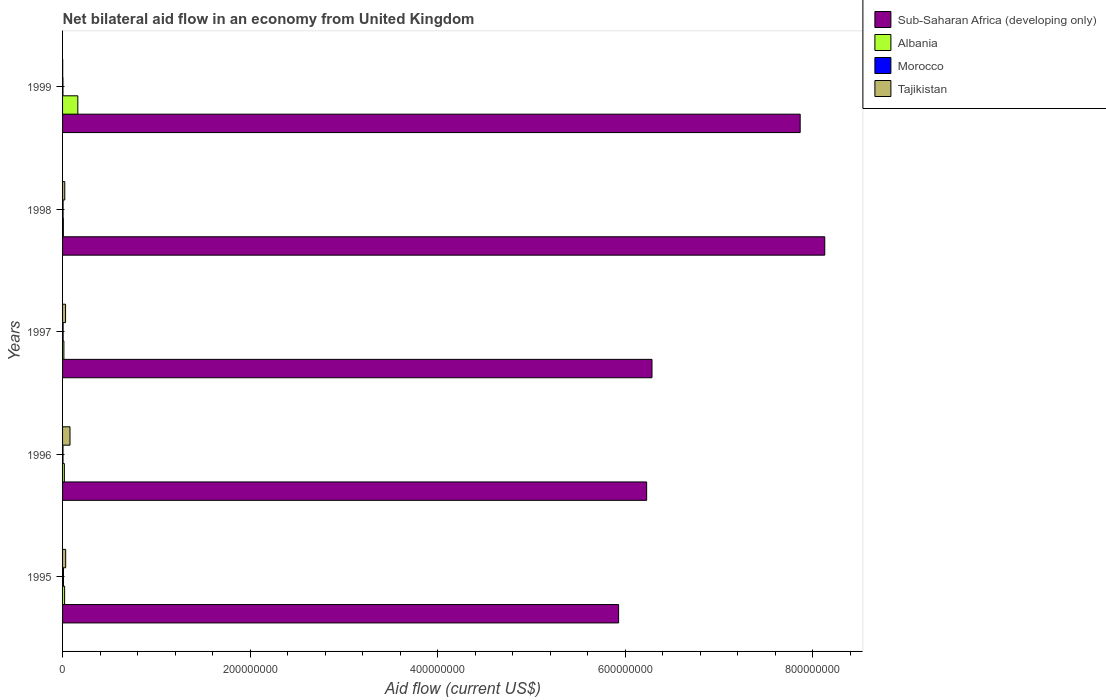Are the number of bars on each tick of the Y-axis equal?
Provide a short and direct response. Yes. How many bars are there on the 3rd tick from the top?
Make the answer very short. 4. What is the label of the 5th group of bars from the top?
Your answer should be very brief. 1995. Across all years, what is the maximum net bilateral aid flow in Morocco?
Your answer should be compact. 9.50e+05. Across all years, what is the minimum net bilateral aid flow in Tajikistan?
Ensure brevity in your answer.  1.30e+05. In which year was the net bilateral aid flow in Morocco minimum?
Keep it short and to the point. 1999. What is the total net bilateral aid flow in Morocco in the graph?
Provide a succinct answer. 2.96e+06. What is the difference between the net bilateral aid flow in Albania in 1995 and that in 1998?
Give a very brief answer. 1.33e+06. What is the difference between the net bilateral aid flow in Morocco in 1995 and the net bilateral aid flow in Albania in 1999?
Your answer should be very brief. -1.53e+07. What is the average net bilateral aid flow in Sub-Saharan Africa (developing only) per year?
Your response must be concise. 6.89e+08. In the year 1998, what is the difference between the net bilateral aid flow in Morocco and net bilateral aid flow in Sub-Saharan Africa (developing only)?
Provide a succinct answer. -8.12e+08. In how many years, is the net bilateral aid flow in Sub-Saharan Africa (developing only) greater than 160000000 US$?
Provide a short and direct response. 5. What is the ratio of the net bilateral aid flow in Tajikistan in 1995 to that in 1996?
Provide a short and direct response. 0.42. Is the net bilateral aid flow in Morocco in 1996 less than that in 1998?
Give a very brief answer. Yes. What is the difference between the highest and the second highest net bilateral aid flow in Albania?
Make the answer very short. 1.41e+07. What is the difference between the highest and the lowest net bilateral aid flow in Sub-Saharan Africa (developing only)?
Make the answer very short. 2.20e+08. What does the 3rd bar from the top in 1999 represents?
Keep it short and to the point. Albania. What does the 4th bar from the bottom in 1999 represents?
Offer a terse response. Tajikistan. Is it the case that in every year, the sum of the net bilateral aid flow in Morocco and net bilateral aid flow in Sub-Saharan Africa (developing only) is greater than the net bilateral aid flow in Tajikistan?
Your response must be concise. Yes. How many bars are there?
Provide a succinct answer. 20. Are the values on the major ticks of X-axis written in scientific E-notation?
Provide a succinct answer. No. How many legend labels are there?
Your answer should be compact. 4. What is the title of the graph?
Your response must be concise. Net bilateral aid flow in an economy from United Kingdom. Does "Monaco" appear as one of the legend labels in the graph?
Your answer should be compact. No. What is the Aid flow (current US$) of Sub-Saharan Africa (developing only) in 1995?
Provide a short and direct response. 5.93e+08. What is the Aid flow (current US$) of Albania in 1995?
Provide a short and direct response. 2.20e+06. What is the Aid flow (current US$) in Morocco in 1995?
Provide a succinct answer. 9.50e+05. What is the Aid flow (current US$) in Tajikistan in 1995?
Your response must be concise. 3.32e+06. What is the Aid flow (current US$) of Sub-Saharan Africa (developing only) in 1996?
Your answer should be very brief. 6.23e+08. What is the Aid flow (current US$) of Albania in 1996?
Make the answer very short. 1.91e+06. What is the Aid flow (current US$) in Morocco in 1996?
Your response must be concise. 4.70e+05. What is the Aid flow (current US$) of Tajikistan in 1996?
Keep it short and to the point. 7.93e+06. What is the Aid flow (current US$) in Sub-Saharan Africa (developing only) in 1997?
Ensure brevity in your answer.  6.28e+08. What is the Aid flow (current US$) of Albania in 1997?
Offer a very short reply. 1.42e+06. What is the Aid flow (current US$) of Morocco in 1997?
Provide a short and direct response. 5.80e+05. What is the Aid flow (current US$) in Tajikistan in 1997?
Provide a succinct answer. 3.19e+06. What is the Aid flow (current US$) of Sub-Saharan Africa (developing only) in 1998?
Give a very brief answer. 8.13e+08. What is the Aid flow (current US$) in Albania in 1998?
Keep it short and to the point. 8.70e+05. What is the Aid flow (current US$) of Morocco in 1998?
Give a very brief answer. 5.40e+05. What is the Aid flow (current US$) in Tajikistan in 1998?
Provide a short and direct response. 2.36e+06. What is the Aid flow (current US$) of Sub-Saharan Africa (developing only) in 1999?
Ensure brevity in your answer.  7.86e+08. What is the Aid flow (current US$) in Albania in 1999?
Your response must be concise. 1.63e+07. What is the Aid flow (current US$) of Morocco in 1999?
Your response must be concise. 4.20e+05. Across all years, what is the maximum Aid flow (current US$) in Sub-Saharan Africa (developing only)?
Your answer should be compact. 8.13e+08. Across all years, what is the maximum Aid flow (current US$) of Albania?
Ensure brevity in your answer.  1.63e+07. Across all years, what is the maximum Aid flow (current US$) in Morocco?
Offer a very short reply. 9.50e+05. Across all years, what is the maximum Aid flow (current US$) in Tajikistan?
Your answer should be very brief. 7.93e+06. Across all years, what is the minimum Aid flow (current US$) in Sub-Saharan Africa (developing only)?
Your response must be concise. 5.93e+08. Across all years, what is the minimum Aid flow (current US$) of Albania?
Keep it short and to the point. 8.70e+05. Across all years, what is the minimum Aid flow (current US$) of Morocco?
Ensure brevity in your answer.  4.20e+05. What is the total Aid flow (current US$) in Sub-Saharan Africa (developing only) in the graph?
Your answer should be compact. 3.44e+09. What is the total Aid flow (current US$) of Albania in the graph?
Your response must be concise. 2.27e+07. What is the total Aid flow (current US$) in Morocco in the graph?
Keep it short and to the point. 2.96e+06. What is the total Aid flow (current US$) in Tajikistan in the graph?
Ensure brevity in your answer.  1.69e+07. What is the difference between the Aid flow (current US$) in Sub-Saharan Africa (developing only) in 1995 and that in 1996?
Your answer should be compact. -2.99e+07. What is the difference between the Aid flow (current US$) of Tajikistan in 1995 and that in 1996?
Your answer should be very brief. -4.61e+06. What is the difference between the Aid flow (current US$) in Sub-Saharan Africa (developing only) in 1995 and that in 1997?
Give a very brief answer. -3.56e+07. What is the difference between the Aid flow (current US$) of Albania in 1995 and that in 1997?
Ensure brevity in your answer.  7.80e+05. What is the difference between the Aid flow (current US$) of Morocco in 1995 and that in 1997?
Offer a terse response. 3.70e+05. What is the difference between the Aid flow (current US$) of Tajikistan in 1995 and that in 1997?
Your response must be concise. 1.30e+05. What is the difference between the Aid flow (current US$) in Sub-Saharan Africa (developing only) in 1995 and that in 1998?
Provide a succinct answer. -2.20e+08. What is the difference between the Aid flow (current US$) in Albania in 1995 and that in 1998?
Your answer should be very brief. 1.33e+06. What is the difference between the Aid flow (current US$) of Tajikistan in 1995 and that in 1998?
Provide a short and direct response. 9.60e+05. What is the difference between the Aid flow (current US$) in Sub-Saharan Africa (developing only) in 1995 and that in 1999?
Your response must be concise. -1.94e+08. What is the difference between the Aid flow (current US$) in Albania in 1995 and that in 1999?
Offer a terse response. -1.41e+07. What is the difference between the Aid flow (current US$) in Morocco in 1995 and that in 1999?
Keep it short and to the point. 5.30e+05. What is the difference between the Aid flow (current US$) of Tajikistan in 1995 and that in 1999?
Your response must be concise. 3.19e+06. What is the difference between the Aid flow (current US$) of Sub-Saharan Africa (developing only) in 1996 and that in 1997?
Ensure brevity in your answer.  -5.70e+06. What is the difference between the Aid flow (current US$) of Tajikistan in 1996 and that in 1997?
Give a very brief answer. 4.74e+06. What is the difference between the Aid flow (current US$) in Sub-Saharan Africa (developing only) in 1996 and that in 1998?
Provide a succinct answer. -1.90e+08. What is the difference between the Aid flow (current US$) of Albania in 1996 and that in 1998?
Your answer should be very brief. 1.04e+06. What is the difference between the Aid flow (current US$) of Tajikistan in 1996 and that in 1998?
Give a very brief answer. 5.57e+06. What is the difference between the Aid flow (current US$) in Sub-Saharan Africa (developing only) in 1996 and that in 1999?
Your response must be concise. -1.64e+08. What is the difference between the Aid flow (current US$) of Albania in 1996 and that in 1999?
Give a very brief answer. -1.44e+07. What is the difference between the Aid flow (current US$) of Tajikistan in 1996 and that in 1999?
Ensure brevity in your answer.  7.80e+06. What is the difference between the Aid flow (current US$) of Sub-Saharan Africa (developing only) in 1997 and that in 1998?
Your response must be concise. -1.84e+08. What is the difference between the Aid flow (current US$) in Albania in 1997 and that in 1998?
Your answer should be very brief. 5.50e+05. What is the difference between the Aid flow (current US$) in Morocco in 1997 and that in 1998?
Make the answer very short. 4.00e+04. What is the difference between the Aid flow (current US$) of Tajikistan in 1997 and that in 1998?
Ensure brevity in your answer.  8.30e+05. What is the difference between the Aid flow (current US$) in Sub-Saharan Africa (developing only) in 1997 and that in 1999?
Make the answer very short. -1.58e+08. What is the difference between the Aid flow (current US$) in Albania in 1997 and that in 1999?
Make the answer very short. -1.49e+07. What is the difference between the Aid flow (current US$) in Tajikistan in 1997 and that in 1999?
Make the answer very short. 3.06e+06. What is the difference between the Aid flow (current US$) in Sub-Saharan Africa (developing only) in 1998 and that in 1999?
Provide a short and direct response. 2.62e+07. What is the difference between the Aid flow (current US$) of Albania in 1998 and that in 1999?
Keep it short and to the point. -1.54e+07. What is the difference between the Aid flow (current US$) of Morocco in 1998 and that in 1999?
Your answer should be compact. 1.20e+05. What is the difference between the Aid flow (current US$) in Tajikistan in 1998 and that in 1999?
Keep it short and to the point. 2.23e+06. What is the difference between the Aid flow (current US$) of Sub-Saharan Africa (developing only) in 1995 and the Aid flow (current US$) of Albania in 1996?
Your response must be concise. 5.91e+08. What is the difference between the Aid flow (current US$) of Sub-Saharan Africa (developing only) in 1995 and the Aid flow (current US$) of Morocco in 1996?
Offer a terse response. 5.92e+08. What is the difference between the Aid flow (current US$) in Sub-Saharan Africa (developing only) in 1995 and the Aid flow (current US$) in Tajikistan in 1996?
Offer a very short reply. 5.85e+08. What is the difference between the Aid flow (current US$) of Albania in 1995 and the Aid flow (current US$) of Morocco in 1996?
Offer a very short reply. 1.73e+06. What is the difference between the Aid flow (current US$) of Albania in 1995 and the Aid flow (current US$) of Tajikistan in 1996?
Your answer should be very brief. -5.73e+06. What is the difference between the Aid flow (current US$) of Morocco in 1995 and the Aid flow (current US$) of Tajikistan in 1996?
Make the answer very short. -6.98e+06. What is the difference between the Aid flow (current US$) of Sub-Saharan Africa (developing only) in 1995 and the Aid flow (current US$) of Albania in 1997?
Keep it short and to the point. 5.91e+08. What is the difference between the Aid flow (current US$) of Sub-Saharan Africa (developing only) in 1995 and the Aid flow (current US$) of Morocco in 1997?
Provide a succinct answer. 5.92e+08. What is the difference between the Aid flow (current US$) in Sub-Saharan Africa (developing only) in 1995 and the Aid flow (current US$) in Tajikistan in 1997?
Ensure brevity in your answer.  5.90e+08. What is the difference between the Aid flow (current US$) of Albania in 1995 and the Aid flow (current US$) of Morocco in 1997?
Ensure brevity in your answer.  1.62e+06. What is the difference between the Aid flow (current US$) in Albania in 1995 and the Aid flow (current US$) in Tajikistan in 1997?
Ensure brevity in your answer.  -9.90e+05. What is the difference between the Aid flow (current US$) in Morocco in 1995 and the Aid flow (current US$) in Tajikistan in 1997?
Keep it short and to the point. -2.24e+06. What is the difference between the Aid flow (current US$) of Sub-Saharan Africa (developing only) in 1995 and the Aid flow (current US$) of Albania in 1998?
Offer a terse response. 5.92e+08. What is the difference between the Aid flow (current US$) of Sub-Saharan Africa (developing only) in 1995 and the Aid flow (current US$) of Morocco in 1998?
Your response must be concise. 5.92e+08. What is the difference between the Aid flow (current US$) of Sub-Saharan Africa (developing only) in 1995 and the Aid flow (current US$) of Tajikistan in 1998?
Your answer should be very brief. 5.90e+08. What is the difference between the Aid flow (current US$) of Albania in 1995 and the Aid flow (current US$) of Morocco in 1998?
Your answer should be very brief. 1.66e+06. What is the difference between the Aid flow (current US$) of Albania in 1995 and the Aid flow (current US$) of Tajikistan in 1998?
Offer a very short reply. -1.60e+05. What is the difference between the Aid flow (current US$) of Morocco in 1995 and the Aid flow (current US$) of Tajikistan in 1998?
Your response must be concise. -1.41e+06. What is the difference between the Aid flow (current US$) of Sub-Saharan Africa (developing only) in 1995 and the Aid flow (current US$) of Albania in 1999?
Your answer should be very brief. 5.77e+08. What is the difference between the Aid flow (current US$) of Sub-Saharan Africa (developing only) in 1995 and the Aid flow (current US$) of Morocco in 1999?
Keep it short and to the point. 5.92e+08. What is the difference between the Aid flow (current US$) of Sub-Saharan Africa (developing only) in 1995 and the Aid flow (current US$) of Tajikistan in 1999?
Keep it short and to the point. 5.93e+08. What is the difference between the Aid flow (current US$) in Albania in 1995 and the Aid flow (current US$) in Morocco in 1999?
Your answer should be compact. 1.78e+06. What is the difference between the Aid flow (current US$) of Albania in 1995 and the Aid flow (current US$) of Tajikistan in 1999?
Give a very brief answer. 2.07e+06. What is the difference between the Aid flow (current US$) of Morocco in 1995 and the Aid flow (current US$) of Tajikistan in 1999?
Your answer should be very brief. 8.20e+05. What is the difference between the Aid flow (current US$) in Sub-Saharan Africa (developing only) in 1996 and the Aid flow (current US$) in Albania in 1997?
Provide a short and direct response. 6.21e+08. What is the difference between the Aid flow (current US$) of Sub-Saharan Africa (developing only) in 1996 and the Aid flow (current US$) of Morocco in 1997?
Keep it short and to the point. 6.22e+08. What is the difference between the Aid flow (current US$) in Sub-Saharan Africa (developing only) in 1996 and the Aid flow (current US$) in Tajikistan in 1997?
Your answer should be very brief. 6.20e+08. What is the difference between the Aid flow (current US$) of Albania in 1996 and the Aid flow (current US$) of Morocco in 1997?
Ensure brevity in your answer.  1.33e+06. What is the difference between the Aid flow (current US$) of Albania in 1996 and the Aid flow (current US$) of Tajikistan in 1997?
Offer a terse response. -1.28e+06. What is the difference between the Aid flow (current US$) in Morocco in 1996 and the Aid flow (current US$) in Tajikistan in 1997?
Your answer should be very brief. -2.72e+06. What is the difference between the Aid flow (current US$) of Sub-Saharan Africa (developing only) in 1996 and the Aid flow (current US$) of Albania in 1998?
Offer a terse response. 6.22e+08. What is the difference between the Aid flow (current US$) in Sub-Saharan Africa (developing only) in 1996 and the Aid flow (current US$) in Morocco in 1998?
Ensure brevity in your answer.  6.22e+08. What is the difference between the Aid flow (current US$) in Sub-Saharan Africa (developing only) in 1996 and the Aid flow (current US$) in Tajikistan in 1998?
Ensure brevity in your answer.  6.20e+08. What is the difference between the Aid flow (current US$) of Albania in 1996 and the Aid flow (current US$) of Morocco in 1998?
Offer a terse response. 1.37e+06. What is the difference between the Aid flow (current US$) in Albania in 1996 and the Aid flow (current US$) in Tajikistan in 1998?
Your answer should be compact. -4.50e+05. What is the difference between the Aid flow (current US$) of Morocco in 1996 and the Aid flow (current US$) of Tajikistan in 1998?
Your answer should be very brief. -1.89e+06. What is the difference between the Aid flow (current US$) of Sub-Saharan Africa (developing only) in 1996 and the Aid flow (current US$) of Albania in 1999?
Ensure brevity in your answer.  6.06e+08. What is the difference between the Aid flow (current US$) in Sub-Saharan Africa (developing only) in 1996 and the Aid flow (current US$) in Morocco in 1999?
Your response must be concise. 6.22e+08. What is the difference between the Aid flow (current US$) in Sub-Saharan Africa (developing only) in 1996 and the Aid flow (current US$) in Tajikistan in 1999?
Offer a very short reply. 6.23e+08. What is the difference between the Aid flow (current US$) of Albania in 1996 and the Aid flow (current US$) of Morocco in 1999?
Your answer should be compact. 1.49e+06. What is the difference between the Aid flow (current US$) in Albania in 1996 and the Aid flow (current US$) in Tajikistan in 1999?
Ensure brevity in your answer.  1.78e+06. What is the difference between the Aid flow (current US$) of Sub-Saharan Africa (developing only) in 1997 and the Aid flow (current US$) of Albania in 1998?
Your response must be concise. 6.28e+08. What is the difference between the Aid flow (current US$) of Sub-Saharan Africa (developing only) in 1997 and the Aid flow (current US$) of Morocco in 1998?
Provide a short and direct response. 6.28e+08. What is the difference between the Aid flow (current US$) of Sub-Saharan Africa (developing only) in 1997 and the Aid flow (current US$) of Tajikistan in 1998?
Provide a short and direct response. 6.26e+08. What is the difference between the Aid flow (current US$) of Albania in 1997 and the Aid flow (current US$) of Morocco in 1998?
Provide a succinct answer. 8.80e+05. What is the difference between the Aid flow (current US$) in Albania in 1997 and the Aid flow (current US$) in Tajikistan in 1998?
Make the answer very short. -9.40e+05. What is the difference between the Aid flow (current US$) of Morocco in 1997 and the Aid flow (current US$) of Tajikistan in 1998?
Ensure brevity in your answer.  -1.78e+06. What is the difference between the Aid flow (current US$) in Sub-Saharan Africa (developing only) in 1997 and the Aid flow (current US$) in Albania in 1999?
Give a very brief answer. 6.12e+08. What is the difference between the Aid flow (current US$) in Sub-Saharan Africa (developing only) in 1997 and the Aid flow (current US$) in Morocco in 1999?
Give a very brief answer. 6.28e+08. What is the difference between the Aid flow (current US$) in Sub-Saharan Africa (developing only) in 1997 and the Aid flow (current US$) in Tajikistan in 1999?
Offer a terse response. 6.28e+08. What is the difference between the Aid flow (current US$) in Albania in 1997 and the Aid flow (current US$) in Tajikistan in 1999?
Your response must be concise. 1.29e+06. What is the difference between the Aid flow (current US$) of Morocco in 1997 and the Aid flow (current US$) of Tajikistan in 1999?
Ensure brevity in your answer.  4.50e+05. What is the difference between the Aid flow (current US$) of Sub-Saharan Africa (developing only) in 1998 and the Aid flow (current US$) of Albania in 1999?
Make the answer very short. 7.96e+08. What is the difference between the Aid flow (current US$) of Sub-Saharan Africa (developing only) in 1998 and the Aid flow (current US$) of Morocco in 1999?
Give a very brief answer. 8.12e+08. What is the difference between the Aid flow (current US$) of Sub-Saharan Africa (developing only) in 1998 and the Aid flow (current US$) of Tajikistan in 1999?
Your answer should be very brief. 8.13e+08. What is the difference between the Aid flow (current US$) in Albania in 1998 and the Aid flow (current US$) in Tajikistan in 1999?
Your answer should be compact. 7.40e+05. What is the difference between the Aid flow (current US$) in Morocco in 1998 and the Aid flow (current US$) in Tajikistan in 1999?
Ensure brevity in your answer.  4.10e+05. What is the average Aid flow (current US$) of Sub-Saharan Africa (developing only) per year?
Make the answer very short. 6.89e+08. What is the average Aid flow (current US$) in Albania per year?
Your answer should be very brief. 4.54e+06. What is the average Aid flow (current US$) in Morocco per year?
Your response must be concise. 5.92e+05. What is the average Aid flow (current US$) of Tajikistan per year?
Provide a succinct answer. 3.39e+06. In the year 1995, what is the difference between the Aid flow (current US$) of Sub-Saharan Africa (developing only) and Aid flow (current US$) of Albania?
Provide a succinct answer. 5.91e+08. In the year 1995, what is the difference between the Aid flow (current US$) in Sub-Saharan Africa (developing only) and Aid flow (current US$) in Morocco?
Give a very brief answer. 5.92e+08. In the year 1995, what is the difference between the Aid flow (current US$) of Sub-Saharan Africa (developing only) and Aid flow (current US$) of Tajikistan?
Make the answer very short. 5.90e+08. In the year 1995, what is the difference between the Aid flow (current US$) in Albania and Aid flow (current US$) in Morocco?
Ensure brevity in your answer.  1.25e+06. In the year 1995, what is the difference between the Aid flow (current US$) of Albania and Aid flow (current US$) of Tajikistan?
Ensure brevity in your answer.  -1.12e+06. In the year 1995, what is the difference between the Aid flow (current US$) of Morocco and Aid flow (current US$) of Tajikistan?
Your response must be concise. -2.37e+06. In the year 1996, what is the difference between the Aid flow (current US$) in Sub-Saharan Africa (developing only) and Aid flow (current US$) in Albania?
Your answer should be very brief. 6.21e+08. In the year 1996, what is the difference between the Aid flow (current US$) in Sub-Saharan Africa (developing only) and Aid flow (current US$) in Morocco?
Your answer should be very brief. 6.22e+08. In the year 1996, what is the difference between the Aid flow (current US$) in Sub-Saharan Africa (developing only) and Aid flow (current US$) in Tajikistan?
Your answer should be compact. 6.15e+08. In the year 1996, what is the difference between the Aid flow (current US$) in Albania and Aid flow (current US$) in Morocco?
Your answer should be compact. 1.44e+06. In the year 1996, what is the difference between the Aid flow (current US$) of Albania and Aid flow (current US$) of Tajikistan?
Make the answer very short. -6.02e+06. In the year 1996, what is the difference between the Aid flow (current US$) in Morocco and Aid flow (current US$) in Tajikistan?
Offer a terse response. -7.46e+06. In the year 1997, what is the difference between the Aid flow (current US$) of Sub-Saharan Africa (developing only) and Aid flow (current US$) of Albania?
Your answer should be compact. 6.27e+08. In the year 1997, what is the difference between the Aid flow (current US$) in Sub-Saharan Africa (developing only) and Aid flow (current US$) in Morocco?
Give a very brief answer. 6.28e+08. In the year 1997, what is the difference between the Aid flow (current US$) in Sub-Saharan Africa (developing only) and Aid flow (current US$) in Tajikistan?
Keep it short and to the point. 6.25e+08. In the year 1997, what is the difference between the Aid flow (current US$) in Albania and Aid flow (current US$) in Morocco?
Offer a very short reply. 8.40e+05. In the year 1997, what is the difference between the Aid flow (current US$) of Albania and Aid flow (current US$) of Tajikistan?
Make the answer very short. -1.77e+06. In the year 1997, what is the difference between the Aid flow (current US$) in Morocco and Aid flow (current US$) in Tajikistan?
Provide a short and direct response. -2.61e+06. In the year 1998, what is the difference between the Aid flow (current US$) in Sub-Saharan Africa (developing only) and Aid flow (current US$) in Albania?
Make the answer very short. 8.12e+08. In the year 1998, what is the difference between the Aid flow (current US$) of Sub-Saharan Africa (developing only) and Aid flow (current US$) of Morocco?
Your response must be concise. 8.12e+08. In the year 1998, what is the difference between the Aid flow (current US$) in Sub-Saharan Africa (developing only) and Aid flow (current US$) in Tajikistan?
Your answer should be compact. 8.10e+08. In the year 1998, what is the difference between the Aid flow (current US$) in Albania and Aid flow (current US$) in Morocco?
Provide a short and direct response. 3.30e+05. In the year 1998, what is the difference between the Aid flow (current US$) of Albania and Aid flow (current US$) of Tajikistan?
Offer a very short reply. -1.49e+06. In the year 1998, what is the difference between the Aid flow (current US$) in Morocco and Aid flow (current US$) in Tajikistan?
Offer a terse response. -1.82e+06. In the year 1999, what is the difference between the Aid flow (current US$) of Sub-Saharan Africa (developing only) and Aid flow (current US$) of Albania?
Give a very brief answer. 7.70e+08. In the year 1999, what is the difference between the Aid flow (current US$) in Sub-Saharan Africa (developing only) and Aid flow (current US$) in Morocco?
Your response must be concise. 7.86e+08. In the year 1999, what is the difference between the Aid flow (current US$) in Sub-Saharan Africa (developing only) and Aid flow (current US$) in Tajikistan?
Offer a very short reply. 7.86e+08. In the year 1999, what is the difference between the Aid flow (current US$) of Albania and Aid flow (current US$) of Morocco?
Ensure brevity in your answer.  1.59e+07. In the year 1999, what is the difference between the Aid flow (current US$) in Albania and Aid flow (current US$) in Tajikistan?
Provide a short and direct response. 1.62e+07. What is the ratio of the Aid flow (current US$) in Sub-Saharan Africa (developing only) in 1995 to that in 1996?
Offer a terse response. 0.95. What is the ratio of the Aid flow (current US$) in Albania in 1995 to that in 1996?
Your response must be concise. 1.15. What is the ratio of the Aid flow (current US$) in Morocco in 1995 to that in 1996?
Offer a very short reply. 2.02. What is the ratio of the Aid flow (current US$) in Tajikistan in 1995 to that in 1996?
Your answer should be very brief. 0.42. What is the ratio of the Aid flow (current US$) in Sub-Saharan Africa (developing only) in 1995 to that in 1997?
Offer a very short reply. 0.94. What is the ratio of the Aid flow (current US$) of Albania in 1995 to that in 1997?
Provide a short and direct response. 1.55. What is the ratio of the Aid flow (current US$) in Morocco in 1995 to that in 1997?
Your response must be concise. 1.64. What is the ratio of the Aid flow (current US$) in Tajikistan in 1995 to that in 1997?
Make the answer very short. 1.04. What is the ratio of the Aid flow (current US$) of Sub-Saharan Africa (developing only) in 1995 to that in 1998?
Ensure brevity in your answer.  0.73. What is the ratio of the Aid flow (current US$) in Albania in 1995 to that in 1998?
Make the answer very short. 2.53. What is the ratio of the Aid flow (current US$) of Morocco in 1995 to that in 1998?
Your answer should be compact. 1.76. What is the ratio of the Aid flow (current US$) in Tajikistan in 1995 to that in 1998?
Make the answer very short. 1.41. What is the ratio of the Aid flow (current US$) in Sub-Saharan Africa (developing only) in 1995 to that in 1999?
Offer a terse response. 0.75. What is the ratio of the Aid flow (current US$) in Albania in 1995 to that in 1999?
Ensure brevity in your answer.  0.14. What is the ratio of the Aid flow (current US$) of Morocco in 1995 to that in 1999?
Offer a very short reply. 2.26. What is the ratio of the Aid flow (current US$) in Tajikistan in 1995 to that in 1999?
Provide a short and direct response. 25.54. What is the ratio of the Aid flow (current US$) in Sub-Saharan Africa (developing only) in 1996 to that in 1997?
Ensure brevity in your answer.  0.99. What is the ratio of the Aid flow (current US$) in Albania in 1996 to that in 1997?
Ensure brevity in your answer.  1.35. What is the ratio of the Aid flow (current US$) in Morocco in 1996 to that in 1997?
Keep it short and to the point. 0.81. What is the ratio of the Aid flow (current US$) in Tajikistan in 1996 to that in 1997?
Make the answer very short. 2.49. What is the ratio of the Aid flow (current US$) in Sub-Saharan Africa (developing only) in 1996 to that in 1998?
Your response must be concise. 0.77. What is the ratio of the Aid flow (current US$) in Albania in 1996 to that in 1998?
Provide a short and direct response. 2.2. What is the ratio of the Aid flow (current US$) of Morocco in 1996 to that in 1998?
Provide a succinct answer. 0.87. What is the ratio of the Aid flow (current US$) in Tajikistan in 1996 to that in 1998?
Provide a short and direct response. 3.36. What is the ratio of the Aid flow (current US$) in Sub-Saharan Africa (developing only) in 1996 to that in 1999?
Keep it short and to the point. 0.79. What is the ratio of the Aid flow (current US$) of Albania in 1996 to that in 1999?
Make the answer very short. 0.12. What is the ratio of the Aid flow (current US$) of Morocco in 1996 to that in 1999?
Give a very brief answer. 1.12. What is the ratio of the Aid flow (current US$) in Sub-Saharan Africa (developing only) in 1997 to that in 1998?
Give a very brief answer. 0.77. What is the ratio of the Aid flow (current US$) of Albania in 1997 to that in 1998?
Your answer should be compact. 1.63. What is the ratio of the Aid flow (current US$) of Morocco in 1997 to that in 1998?
Offer a very short reply. 1.07. What is the ratio of the Aid flow (current US$) in Tajikistan in 1997 to that in 1998?
Your answer should be compact. 1.35. What is the ratio of the Aid flow (current US$) of Sub-Saharan Africa (developing only) in 1997 to that in 1999?
Offer a terse response. 0.8. What is the ratio of the Aid flow (current US$) in Albania in 1997 to that in 1999?
Make the answer very short. 0.09. What is the ratio of the Aid flow (current US$) in Morocco in 1997 to that in 1999?
Provide a short and direct response. 1.38. What is the ratio of the Aid flow (current US$) in Tajikistan in 1997 to that in 1999?
Your answer should be very brief. 24.54. What is the ratio of the Aid flow (current US$) in Sub-Saharan Africa (developing only) in 1998 to that in 1999?
Your response must be concise. 1.03. What is the ratio of the Aid flow (current US$) in Albania in 1998 to that in 1999?
Offer a terse response. 0.05. What is the ratio of the Aid flow (current US$) in Morocco in 1998 to that in 1999?
Provide a short and direct response. 1.29. What is the ratio of the Aid flow (current US$) of Tajikistan in 1998 to that in 1999?
Keep it short and to the point. 18.15. What is the difference between the highest and the second highest Aid flow (current US$) of Sub-Saharan Africa (developing only)?
Your response must be concise. 2.62e+07. What is the difference between the highest and the second highest Aid flow (current US$) of Albania?
Make the answer very short. 1.41e+07. What is the difference between the highest and the second highest Aid flow (current US$) in Morocco?
Provide a succinct answer. 3.70e+05. What is the difference between the highest and the second highest Aid flow (current US$) of Tajikistan?
Keep it short and to the point. 4.61e+06. What is the difference between the highest and the lowest Aid flow (current US$) of Sub-Saharan Africa (developing only)?
Make the answer very short. 2.20e+08. What is the difference between the highest and the lowest Aid flow (current US$) in Albania?
Provide a succinct answer. 1.54e+07. What is the difference between the highest and the lowest Aid flow (current US$) of Morocco?
Your response must be concise. 5.30e+05. What is the difference between the highest and the lowest Aid flow (current US$) of Tajikistan?
Your answer should be compact. 7.80e+06. 